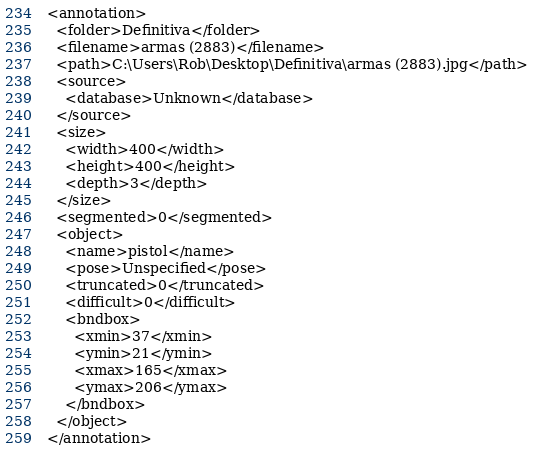Convert code to text. <code><loc_0><loc_0><loc_500><loc_500><_XML_><annotation>
  <folder>Definitiva</folder>
  <filename>armas (2883)</filename>
  <path>C:\Users\Rob\Desktop\Definitiva\armas (2883).jpg</path>
  <source>
    <database>Unknown</database>
  </source>
  <size>
    <width>400</width>
    <height>400</height>
    <depth>3</depth>
  </size>
  <segmented>0</segmented>
  <object>
    <name>pistol</name>
    <pose>Unspecified</pose>
    <truncated>0</truncated>
    <difficult>0</difficult>
    <bndbox>
      <xmin>37</xmin>
      <ymin>21</ymin>
      <xmax>165</xmax>
      <ymax>206</ymax>
    </bndbox>
  </object>
</annotation>
</code> 